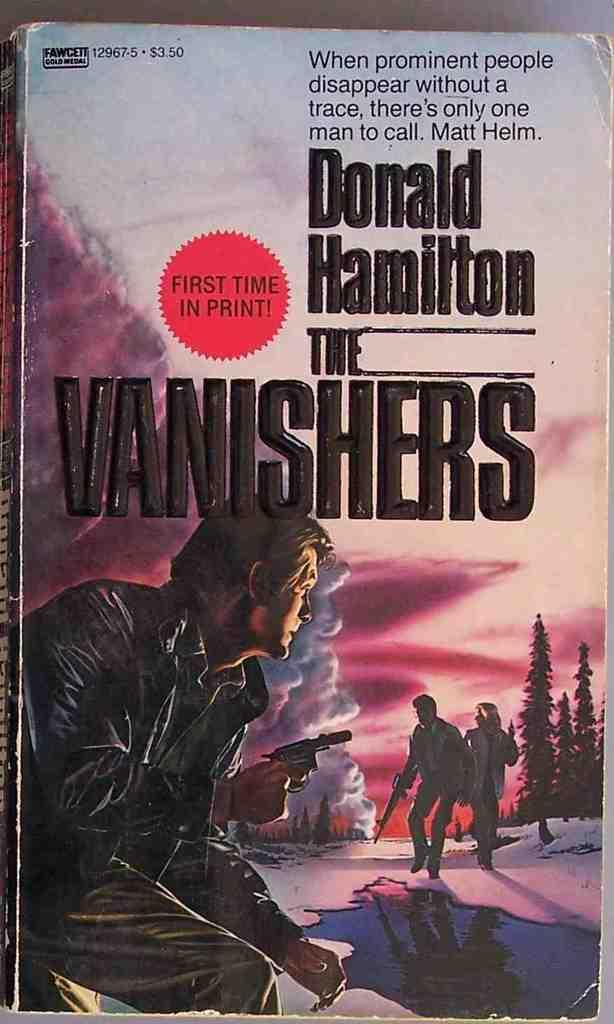<image>
Provide a brief description of the given image. The book The Vanishers written by Donald Hamilton. 